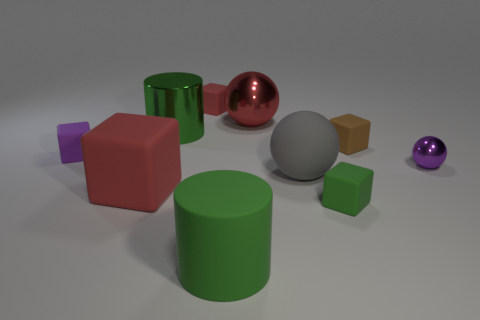Subtract all brown blocks. How many blocks are left? 4 Subtract all small brown cubes. How many cubes are left? 4 Subtract 1 blocks. How many blocks are left? 4 Subtract all green blocks. Subtract all red cylinders. How many blocks are left? 4 Subtract all spheres. How many objects are left? 7 Add 9 big green metal objects. How many big green metal objects are left? 10 Add 6 large brown shiny things. How many large brown shiny things exist? 6 Subtract 0 cyan spheres. How many objects are left? 10 Subtract all brown things. Subtract all big matte things. How many objects are left? 6 